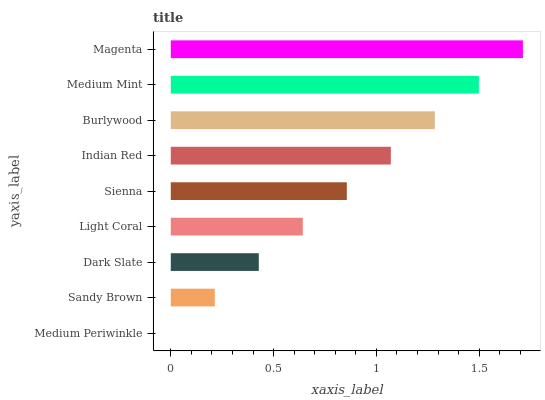Is Medium Periwinkle the minimum?
Answer yes or no. Yes. Is Magenta the maximum?
Answer yes or no. Yes. Is Sandy Brown the minimum?
Answer yes or no. No. Is Sandy Brown the maximum?
Answer yes or no. No. Is Sandy Brown greater than Medium Periwinkle?
Answer yes or no. Yes. Is Medium Periwinkle less than Sandy Brown?
Answer yes or no. Yes. Is Medium Periwinkle greater than Sandy Brown?
Answer yes or no. No. Is Sandy Brown less than Medium Periwinkle?
Answer yes or no. No. Is Sienna the high median?
Answer yes or no. Yes. Is Sienna the low median?
Answer yes or no. Yes. Is Indian Red the high median?
Answer yes or no. No. Is Medium Periwinkle the low median?
Answer yes or no. No. 